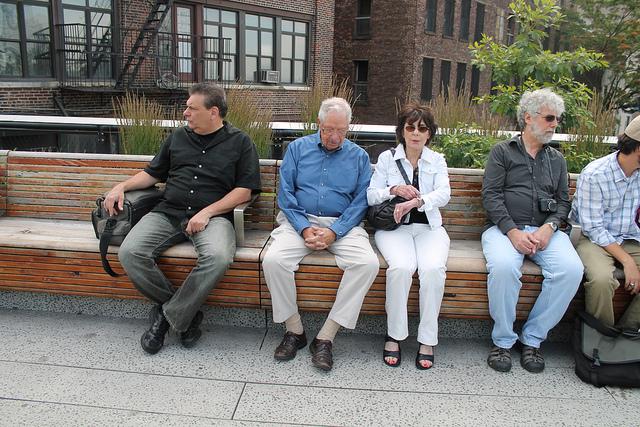Does the man in the blue shirt have his eyes open?
Answer briefly. No. How many people wearing glasses?
Quick response, please. 2. How many men are in this image?
Concise answer only. 4. 